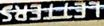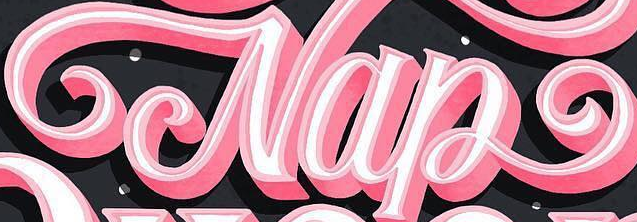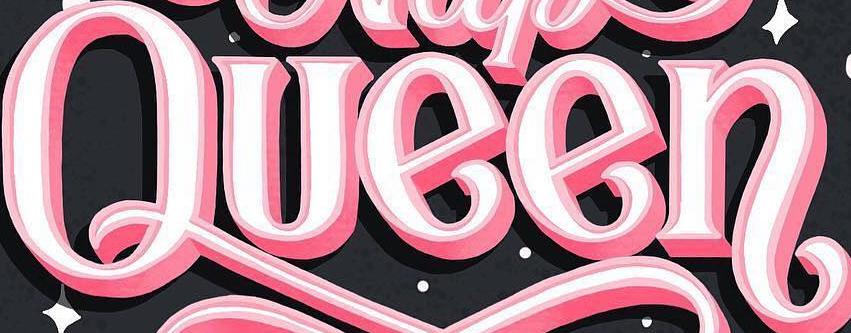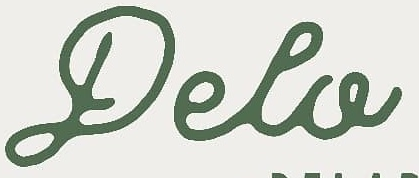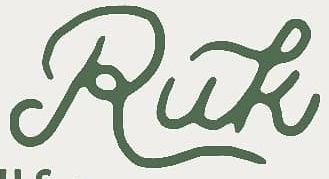Transcribe the words shown in these images in order, separated by a semicolon. LETTERS; Nap; Queen; Pela; Ruk 